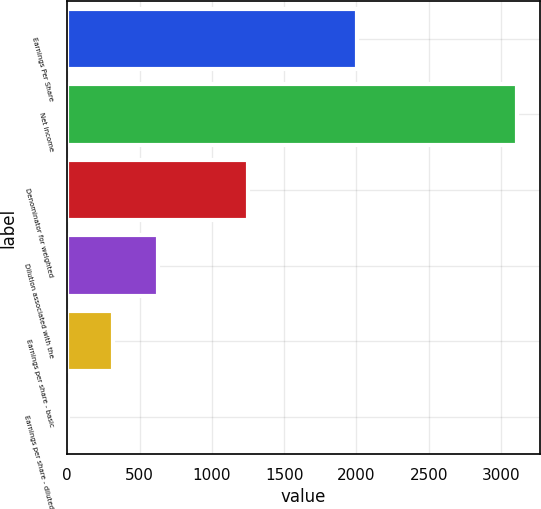Convert chart to OTSL. <chart><loc_0><loc_0><loc_500><loc_500><bar_chart><fcel>Earnings Per Share<fcel>Net income<fcel>Denominator for weighted<fcel>Dilution associated with the<fcel>Earnings per share - basic<fcel>Earnings per share - diluted<nl><fcel>2005<fcel>3111<fcel>1246.78<fcel>625.38<fcel>314.68<fcel>3.98<nl></chart> 